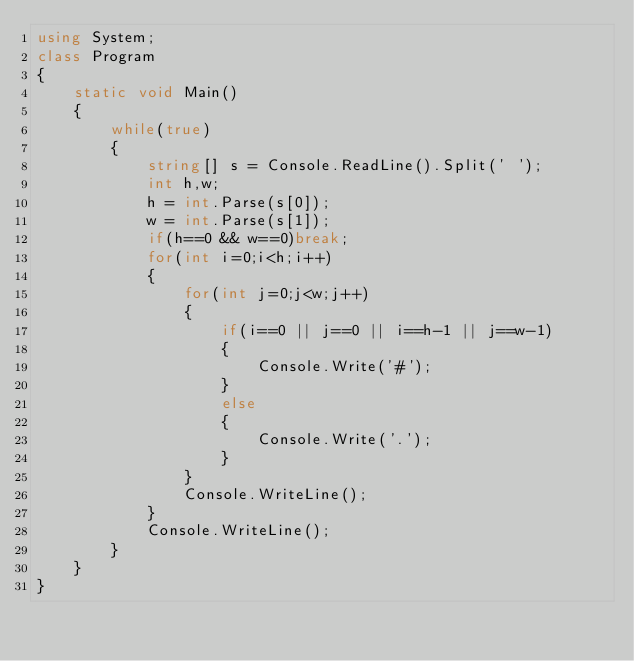Convert code to text. <code><loc_0><loc_0><loc_500><loc_500><_C#_>using System;
class Program
{
    static void Main()
    {
        while(true)
        {
            string[] s = Console.ReadLine().Split(' ');
            int h,w;
            h = int.Parse(s[0]);
            w = int.Parse(s[1]);
            if(h==0 && w==0)break;
            for(int i=0;i<h;i++)
            {
                for(int j=0;j<w;j++)
                {
                    if(i==0 || j==0 || i==h-1 || j==w-1)
                    {
                        Console.Write('#');
                    }
                    else
                    {
                        Console.Write('.');
                    }
                }
                Console.WriteLine();
            }
            Console.WriteLine();
        }
    }
}

</code> 